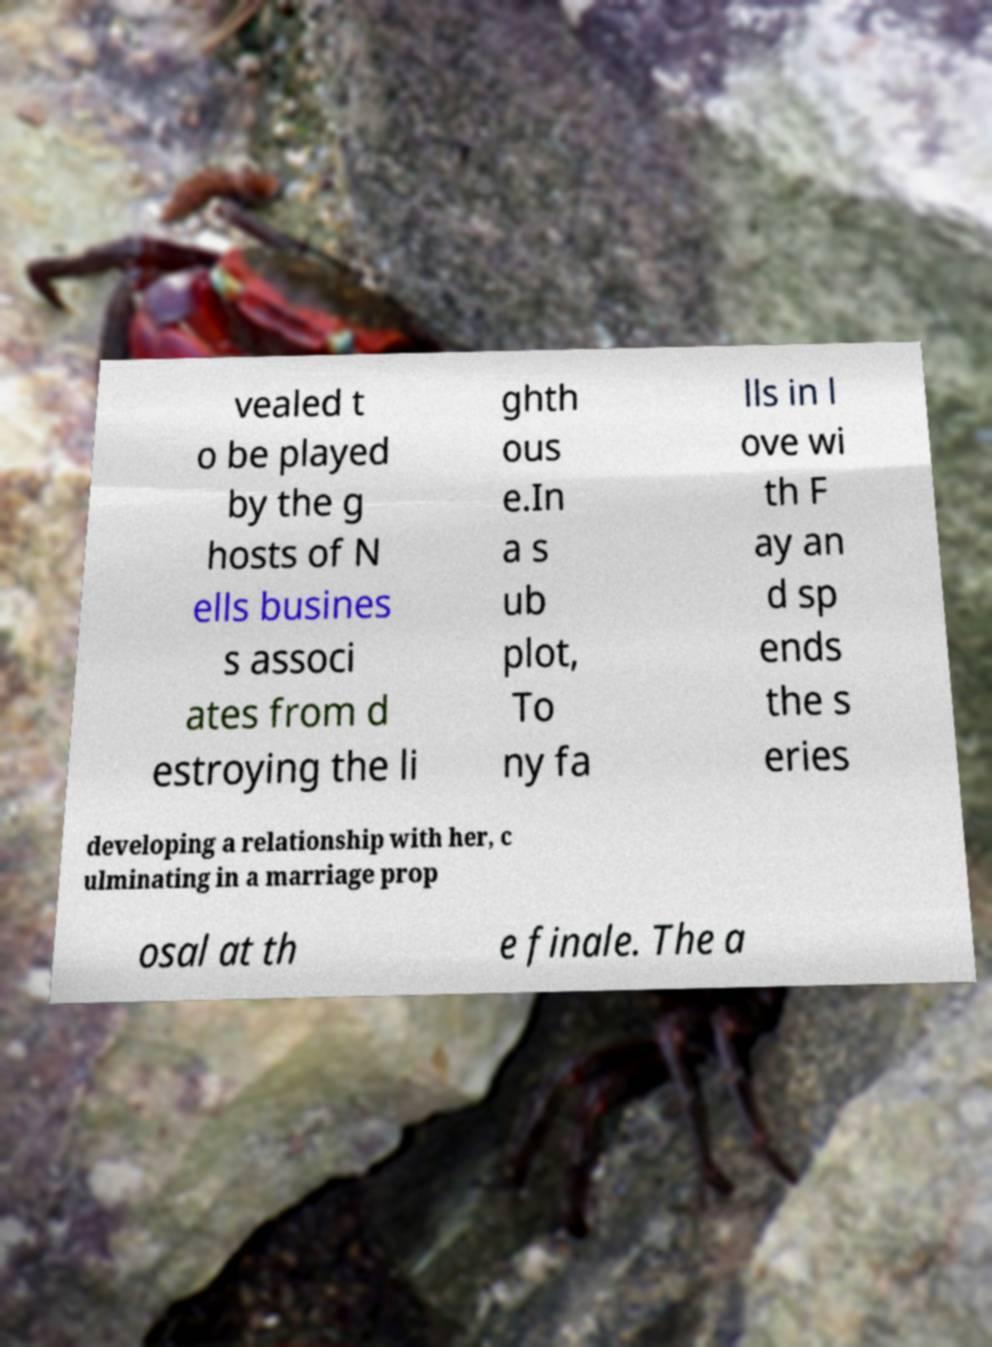For documentation purposes, I need the text within this image transcribed. Could you provide that? vealed t o be played by the g hosts of N ells busines s associ ates from d estroying the li ghth ous e.In a s ub plot, To ny fa lls in l ove wi th F ay an d sp ends the s eries developing a relationship with her, c ulminating in a marriage prop osal at th e finale. The a 